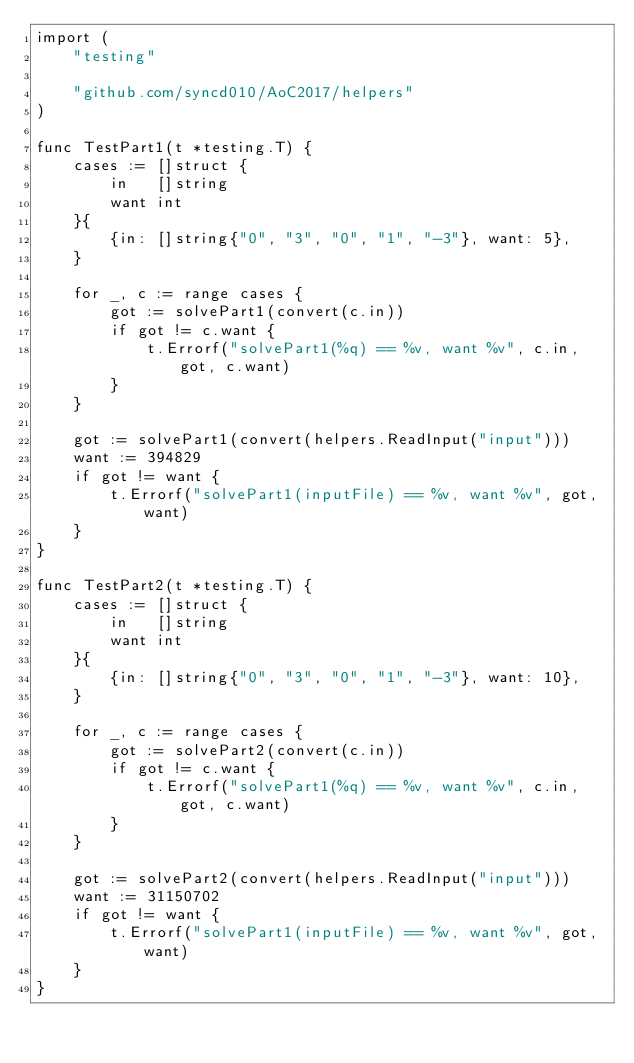Convert code to text. <code><loc_0><loc_0><loc_500><loc_500><_Go_>import (
	"testing"

	"github.com/syncd010/AoC2017/helpers"
)

func TestPart1(t *testing.T) {
	cases := []struct {
		in   []string
		want int
	}{
		{in: []string{"0", "3", "0", "1", "-3"}, want: 5},
	}

	for _, c := range cases {
		got := solvePart1(convert(c.in))
		if got != c.want {
			t.Errorf("solvePart1(%q) == %v, want %v", c.in, got, c.want)
		}
	}

	got := solvePart1(convert(helpers.ReadInput("input")))
	want := 394829
	if got != want {
		t.Errorf("solvePart1(inputFile) == %v, want %v", got, want)
	}
}

func TestPart2(t *testing.T) {
	cases := []struct {
		in   []string
		want int
	}{
		{in: []string{"0", "3", "0", "1", "-3"}, want: 10},
	}

	for _, c := range cases {
		got := solvePart2(convert(c.in))
		if got != c.want {
			t.Errorf("solvePart1(%q) == %v, want %v", c.in, got, c.want)
		}
	}

	got := solvePart2(convert(helpers.ReadInput("input")))
	want := 31150702
	if got != want {
		t.Errorf("solvePart1(inputFile) == %v, want %v", got, want)
	}
}
</code> 